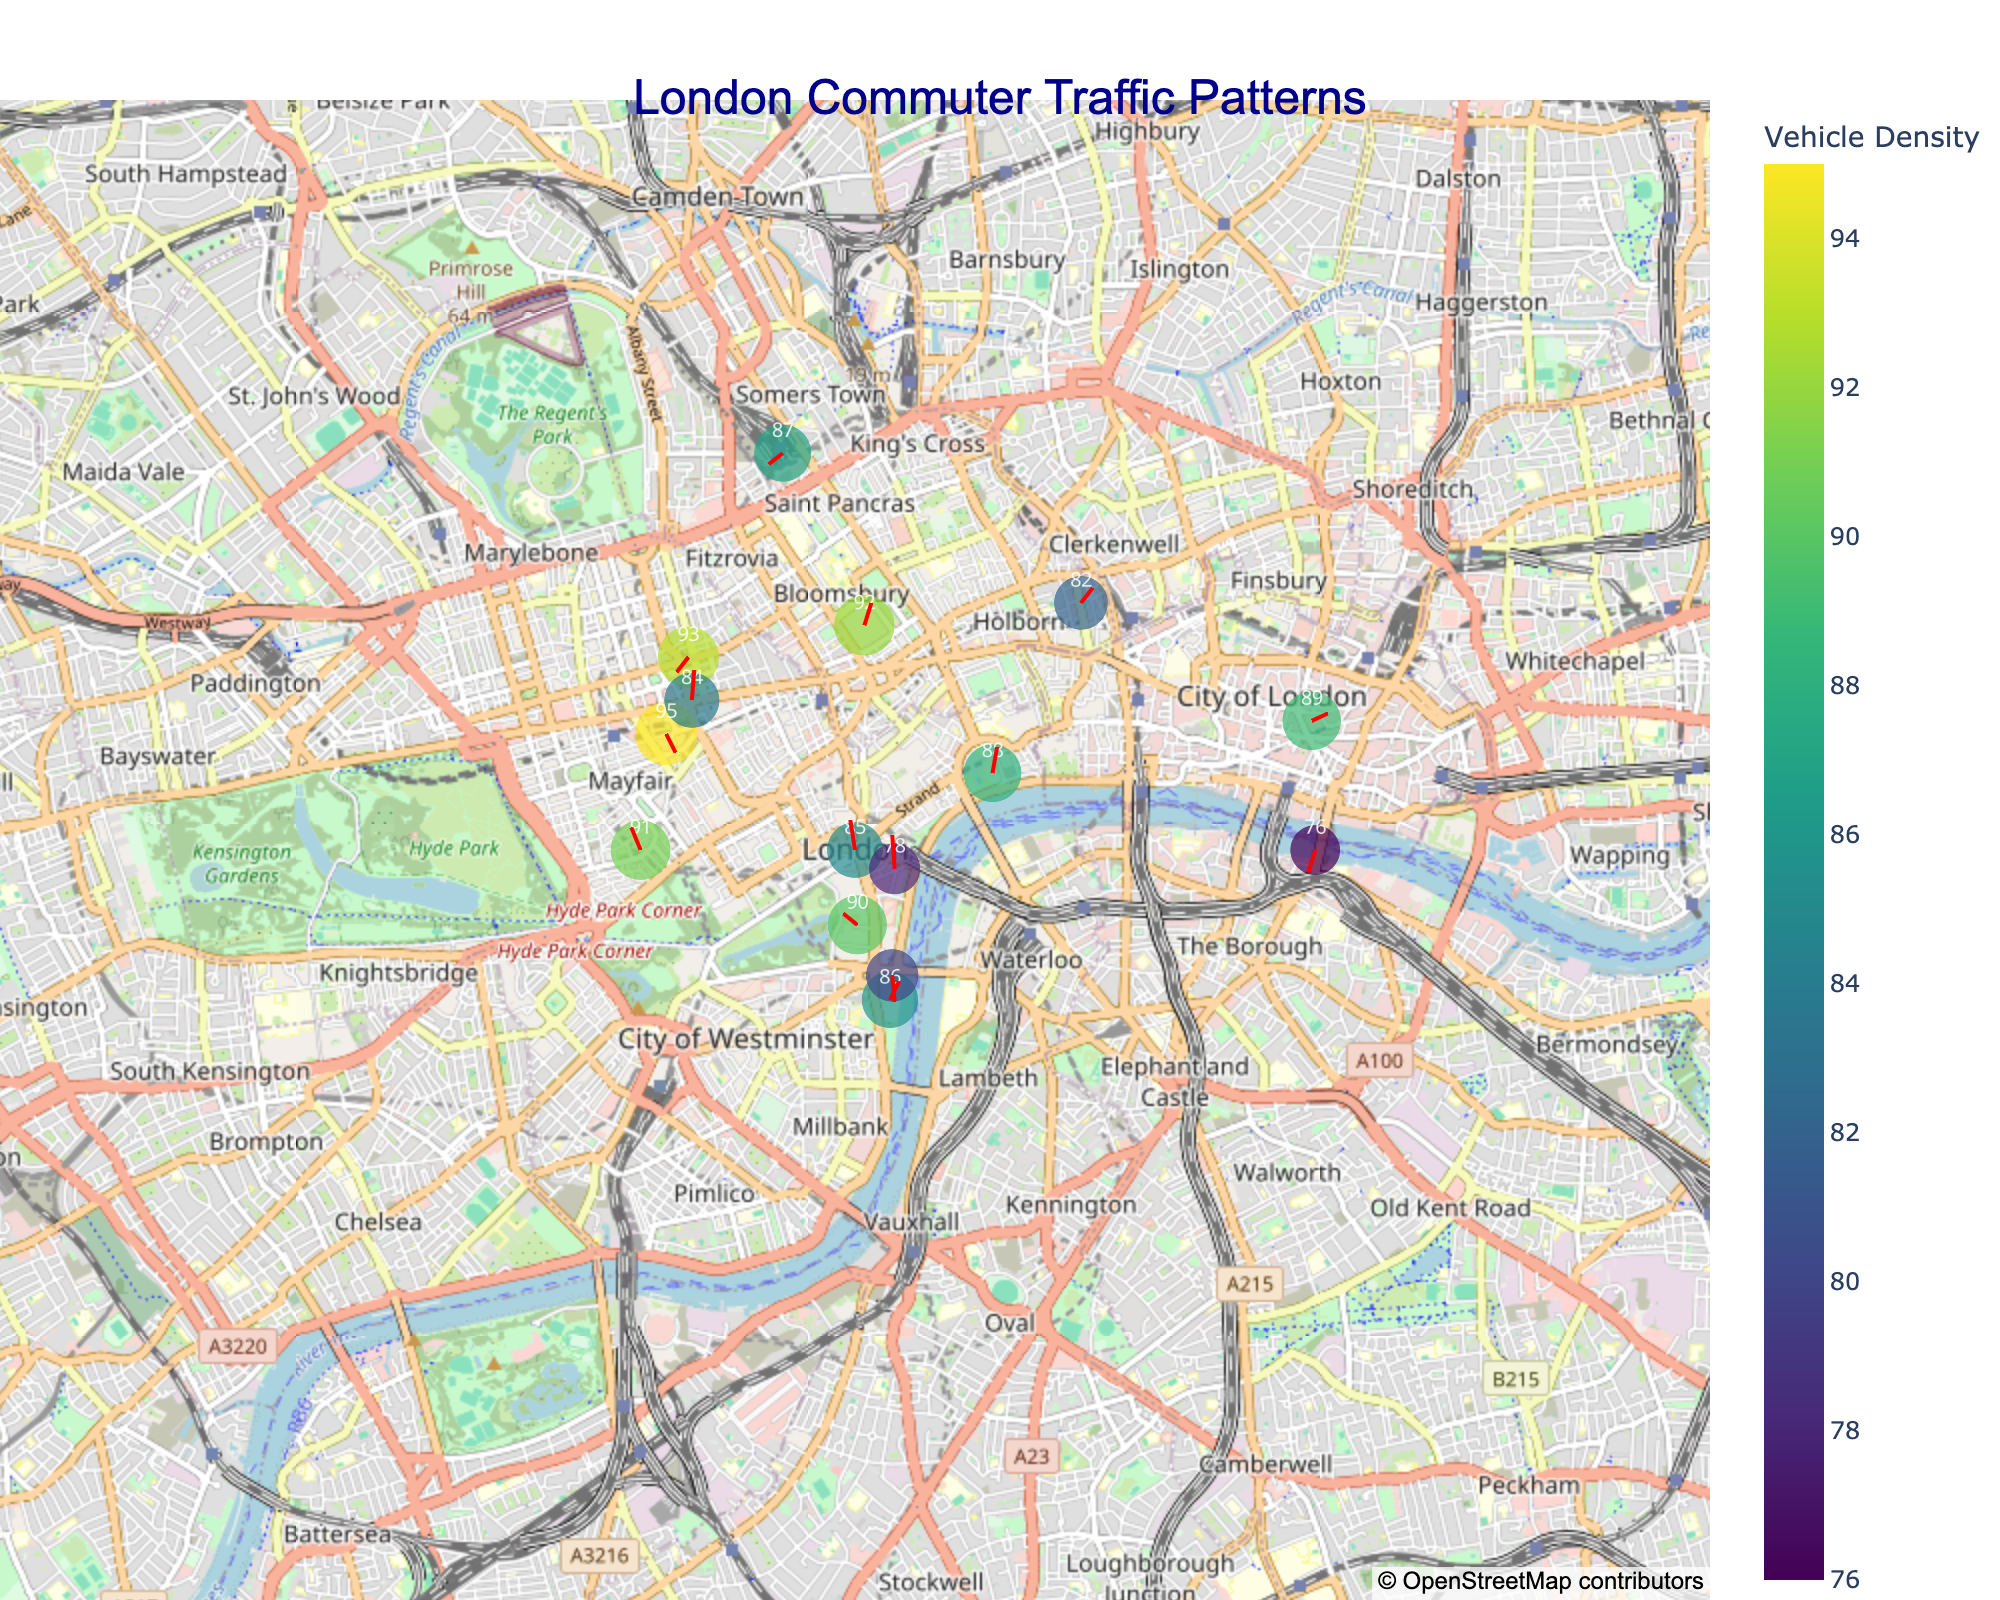what is the title of the figure? The title of the figure is typically displayed at the top center of the plot. In this case, it is "London Commuter Traffic Patterns" which reflects the content being presented.
Answer: London Commuter Traffic Patterns What is the highest vehicle density shown on the figure? To find the highest vehicle density, look at the color bar and the values displayed on the scatter points. The highest density value among the points is 95.
Answer: 95 What direction do the arrows point in at location (51.5034, -0.1276)? We look at the specific location on the map and observe the orientation of the arrow at that point. The direction vector (u, v) at this location is (0.3, -0.6), so the arrow points in a north-east direction with a slight northward component.
Answer: (0.3, -0.6) Between which coordinates do we see a vehicle density of 93? By cross-referencing the density value of 93, we identify the coordinates (51.5177, -0.1421) corresponding to this density value.
Answer: (51.5177, -0.1421) Which location has the largest size markers on the plot? The size of the markers is proportional to the vehicle density divided by 3. By observing the plot, the point with the highest density of 95 will have the largest marker size. This corresponds to the coordinates (51.5136, -0.1440).
Answer: (51.5136, -0.1440) What are the hover text details shown for the point at coordinates (51.5074, -0.1278)? Hover over the specific location on the plot to see the details. The hover text typically includes vehicle density and direction. In this case, it would display "Density: 85<br>Direction: (0.8, -0.2)".
Answer: Density: 85<br>Direction: (0.8, -0.2) How do the directions of the arrows at coordinates (51.5115, -0.1160) and (51.5154, -0.1418) compare? By looking at both coordinates on the map and comparing the vectors, we see that (51.5115, -0.1160) has a direction vector of (0.7, 0.2) and (51.5154, -0.1418) has a direction vector of (0.8, 0.1). Both arrows point roughly to the north-east, but the first vector is slightly less horizontal.
Answer: Both point north-east, with the first being less horizontal What are the sum of vehicle densities for the locations with coordinates starting with 51.51? We sum the densities for all coordinates beginning with 51.51, which are 85, 88, 95, 89, 91, and 84. The total sum is 85 + 88 + 95 + 89 + 91 + 84 = 532.
Answer: 532 Which point displays the smallest arrow length, and what is its density? Arrow length is determined by the magnitude of the direction vector (u, v). The point with coordinates (51.5143, -0.0886) has the smallest vector magnitude (0.2, 0.7) with the magnitude calculated as √(0.2² + 0.7²) ≈ 0.729. Its density is 89.
Answer: (51.5143, -0.0886), 89 